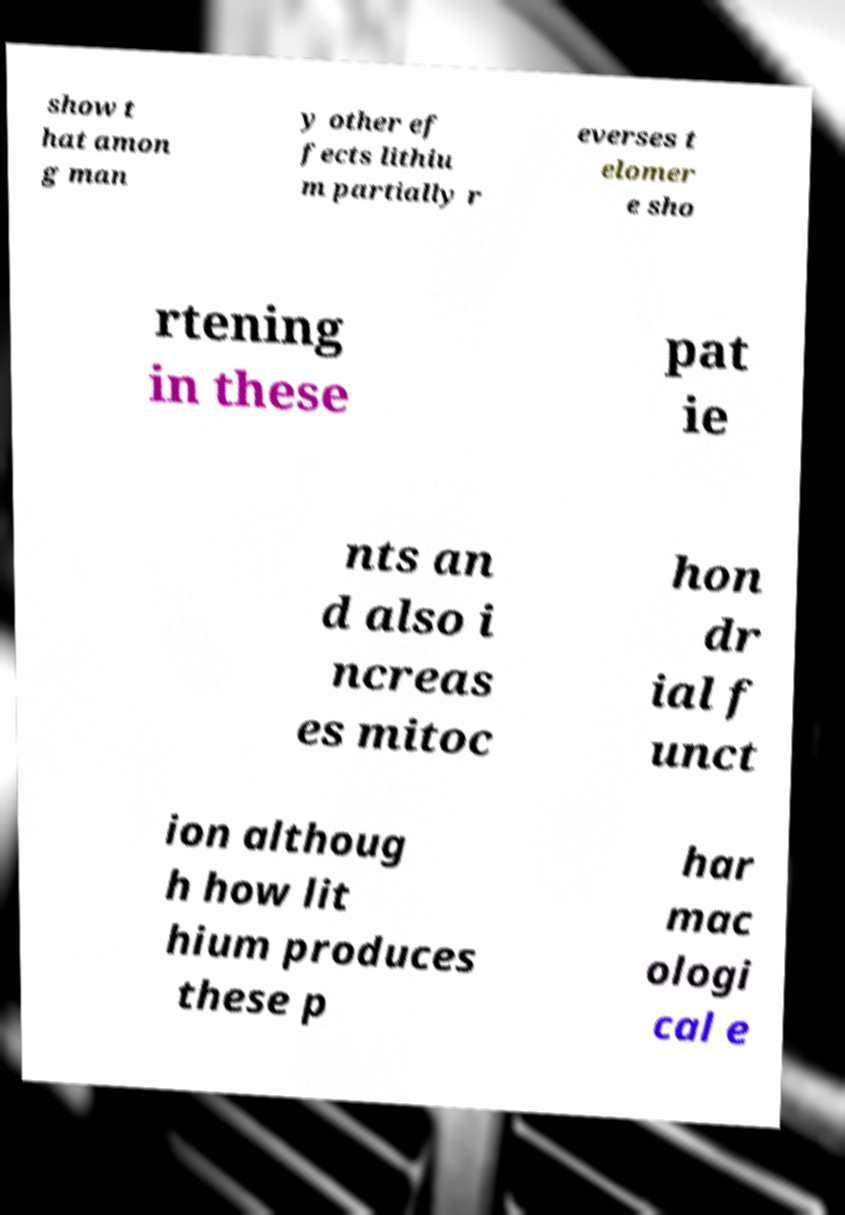I need the written content from this picture converted into text. Can you do that? show t hat amon g man y other ef fects lithiu m partially r everses t elomer e sho rtening in these pat ie nts an d also i ncreas es mitoc hon dr ial f unct ion althoug h how lit hium produces these p har mac ologi cal e 